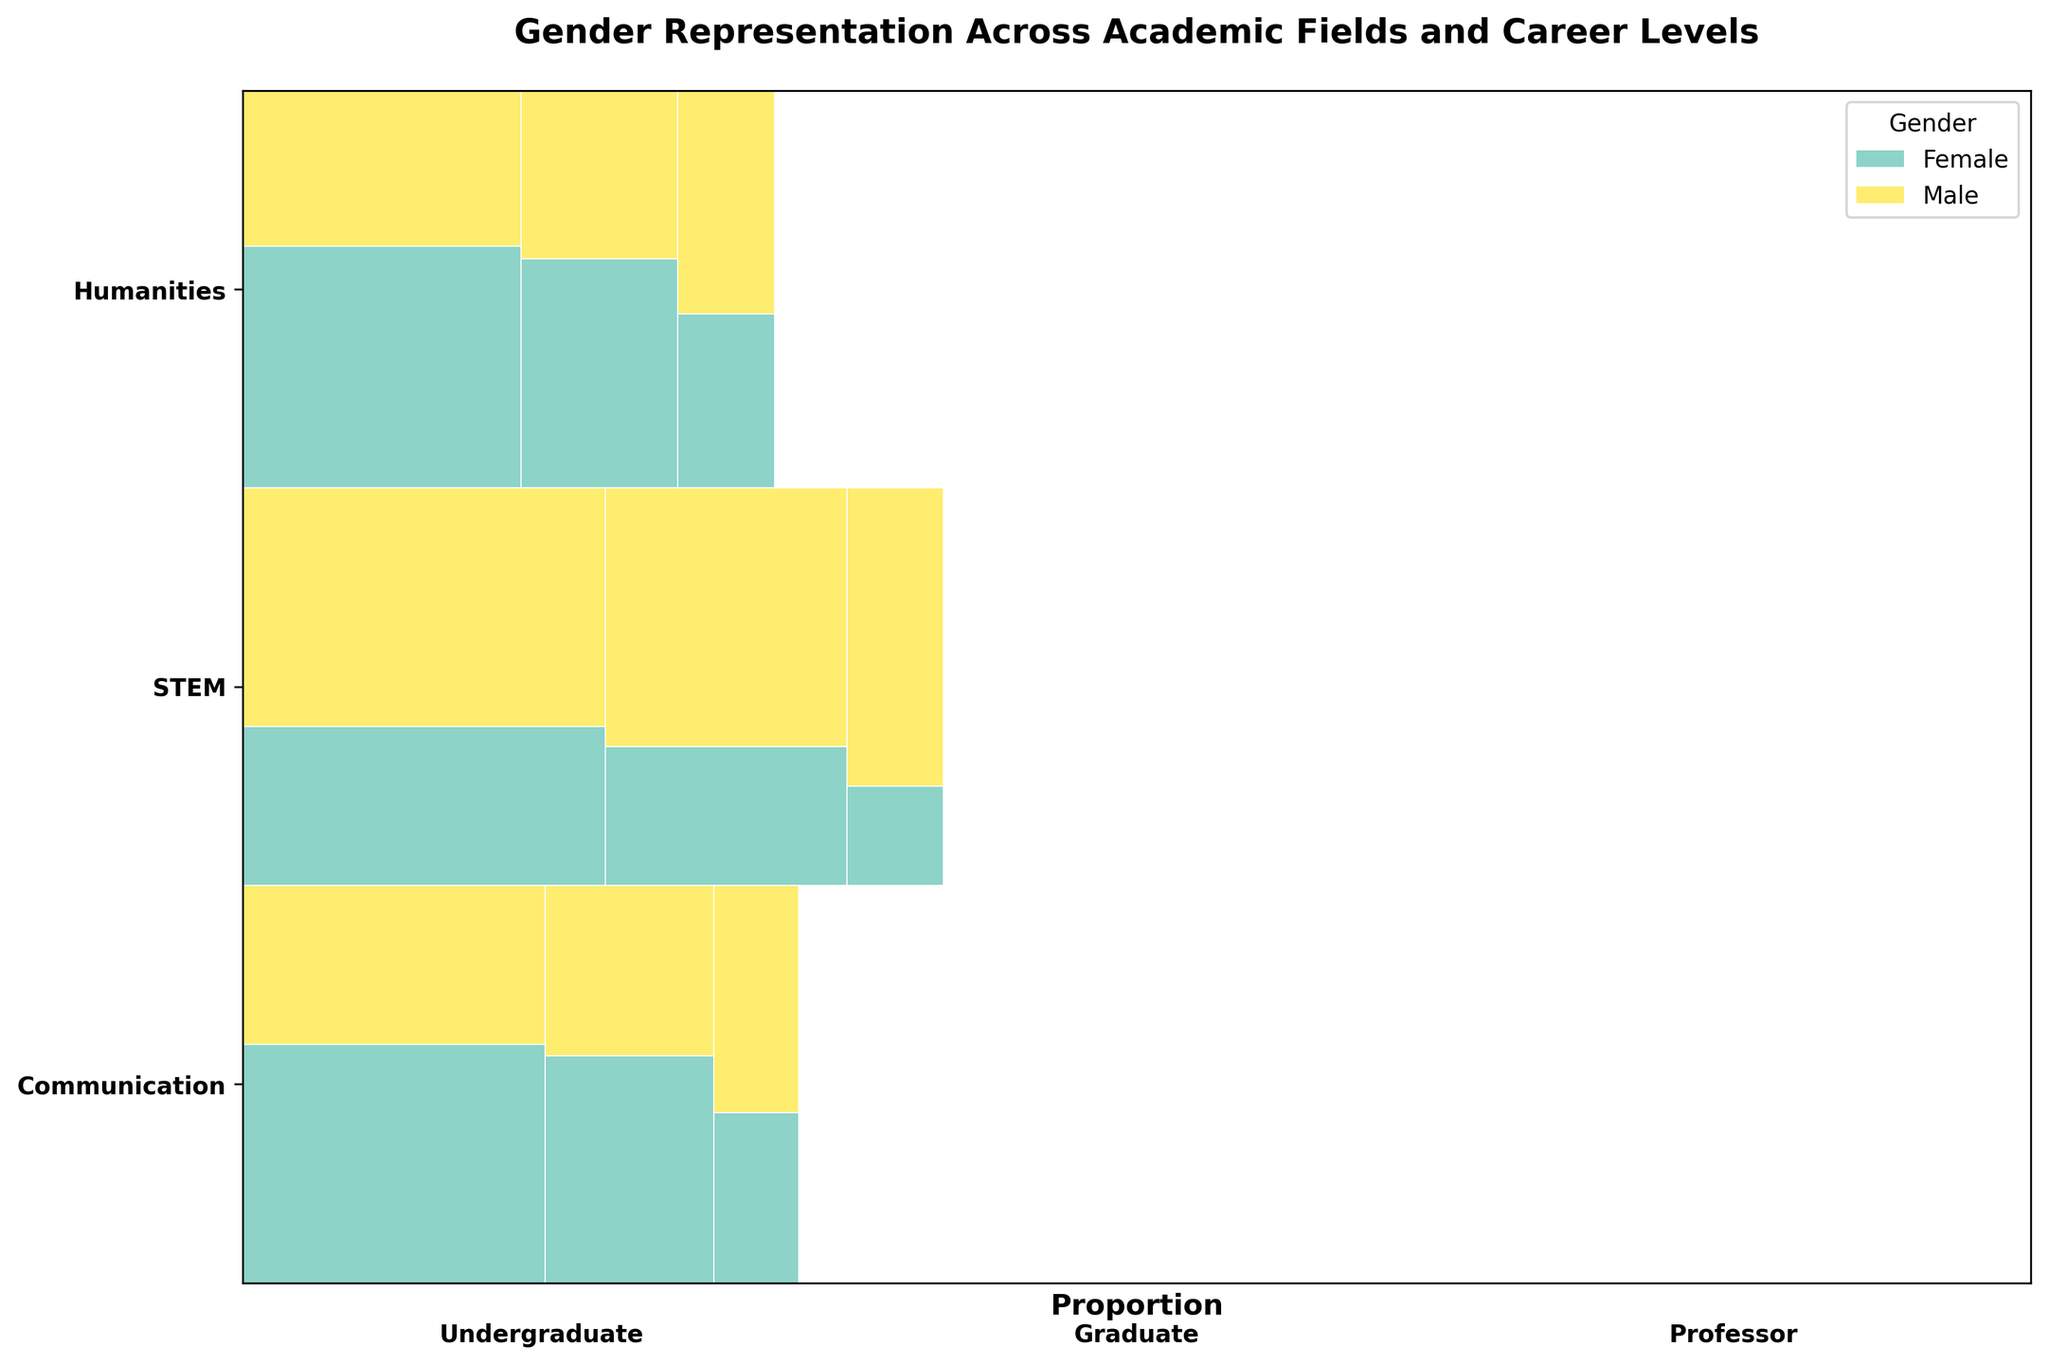How many colors are used to represent gender in the plot? The plot uses colors to represent different genders. By looking at the legend, we can see that there are distinct colors representing "Female" and "Male".
Answer: Two What is the approximate proportion of females at the undergraduate level in the Communication field? To find this, we look at the height of the female segment in the Communication undergraduate section compared to the total height of that bar. It appears roughly 60% of the bar is female.
Answer: 60% Which career level in STEM has the higher proportion of males? Observing the segments for males at each career level in STEM, the professor level has the largest male segment.
Answer: Professor Does the Humanities field have more female or male professors? By comparing the size of the female and male segments within the Humanities professor section, the female segment is slightly larger.
Answer: Female What is the difference in the number of female graduate students between STEM and Humanities? First, find the female segments in STEM and Humanities at the graduate level. STEM has 70 and Humanities has 75. The difference is 75 - 70 = 5.
Answer: 5 Among all fields, at which career level is the proportion of females the lowest? Look for the smallest female segment across all fields and career levels. The STEM professor level shows the most diminutive female segment.
Answer: Professor in STEM Is there a field where a gender balance is approximately achieved at the undergraduate level? Look for an undergraduate level where male and female segments are roughly equal. In Communication, the segments look fairly balanced.
Answer: Communication Which field has the least gender disparity overall? Assess the overall visual impression by comparing the balance in gender proportions across all levels for each field. Humanities generally shows less disparity compared to STEM and Communication.
Answer: Humanities What trend can be observed among the female representation as the career level progresses in STEM? Examine the female segments in STEM across undergraduate, graduate, and professor levels. Female representation decreases significantly progressing from undergraduate to professor.
Answer: Decreases 